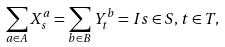<formula> <loc_0><loc_0><loc_500><loc_500>\sum _ { a \in A } X _ { s } ^ { a } = \sum _ { b \in B } Y _ { t } ^ { b } = I s \in S , t \in T ,</formula> 